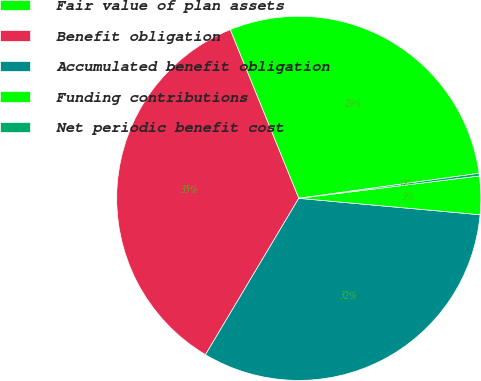Convert chart. <chart><loc_0><loc_0><loc_500><loc_500><pie_chart><fcel>Fair value of plan assets<fcel>Benefit obligation<fcel>Accumulated benefit obligation<fcel>Funding contributions<fcel>Net periodic benefit cost<nl><fcel>28.95%<fcel>35.29%<fcel>32.12%<fcel>3.4%<fcel>0.23%<nl></chart> 